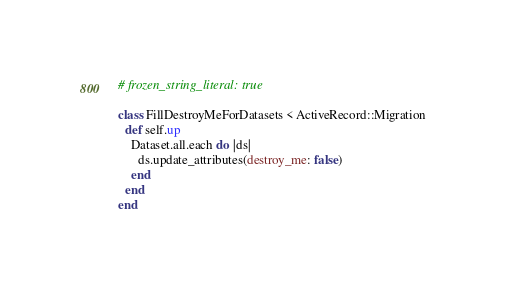<code> <loc_0><loc_0><loc_500><loc_500><_Ruby_># frozen_string_literal: true

class FillDestroyMeForDatasets < ActiveRecord::Migration
  def self.up
    Dataset.all.each do |ds|
      ds.update_attributes(destroy_me: false)
    end
  end
end
</code> 